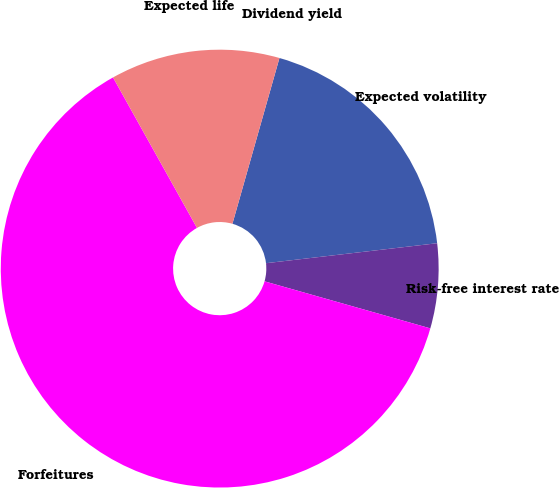<chart> <loc_0><loc_0><loc_500><loc_500><pie_chart><fcel>Dividend yield<fcel>Expected volatility<fcel>Risk-free interest rate<fcel>Forfeitures<fcel>Expected life<nl><fcel>0.0%<fcel>18.75%<fcel>6.25%<fcel>62.5%<fcel>12.5%<nl></chart> 